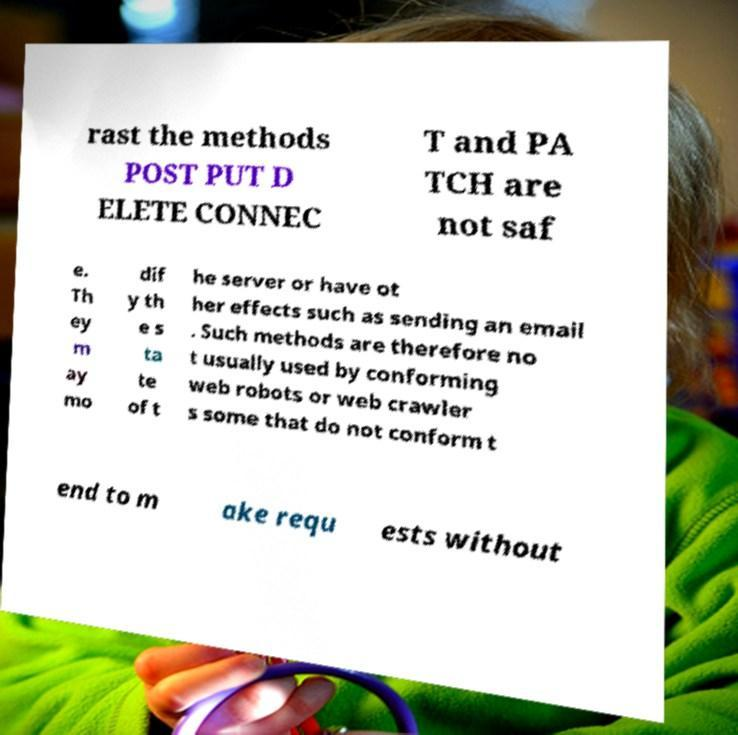Please read and relay the text visible in this image. What does it say? rast the methods POST PUT D ELETE CONNEC T and PA TCH are not saf e. Th ey m ay mo dif y th e s ta te of t he server or have ot her effects such as sending an email . Such methods are therefore no t usually used by conforming web robots or web crawler s some that do not conform t end to m ake requ ests without 